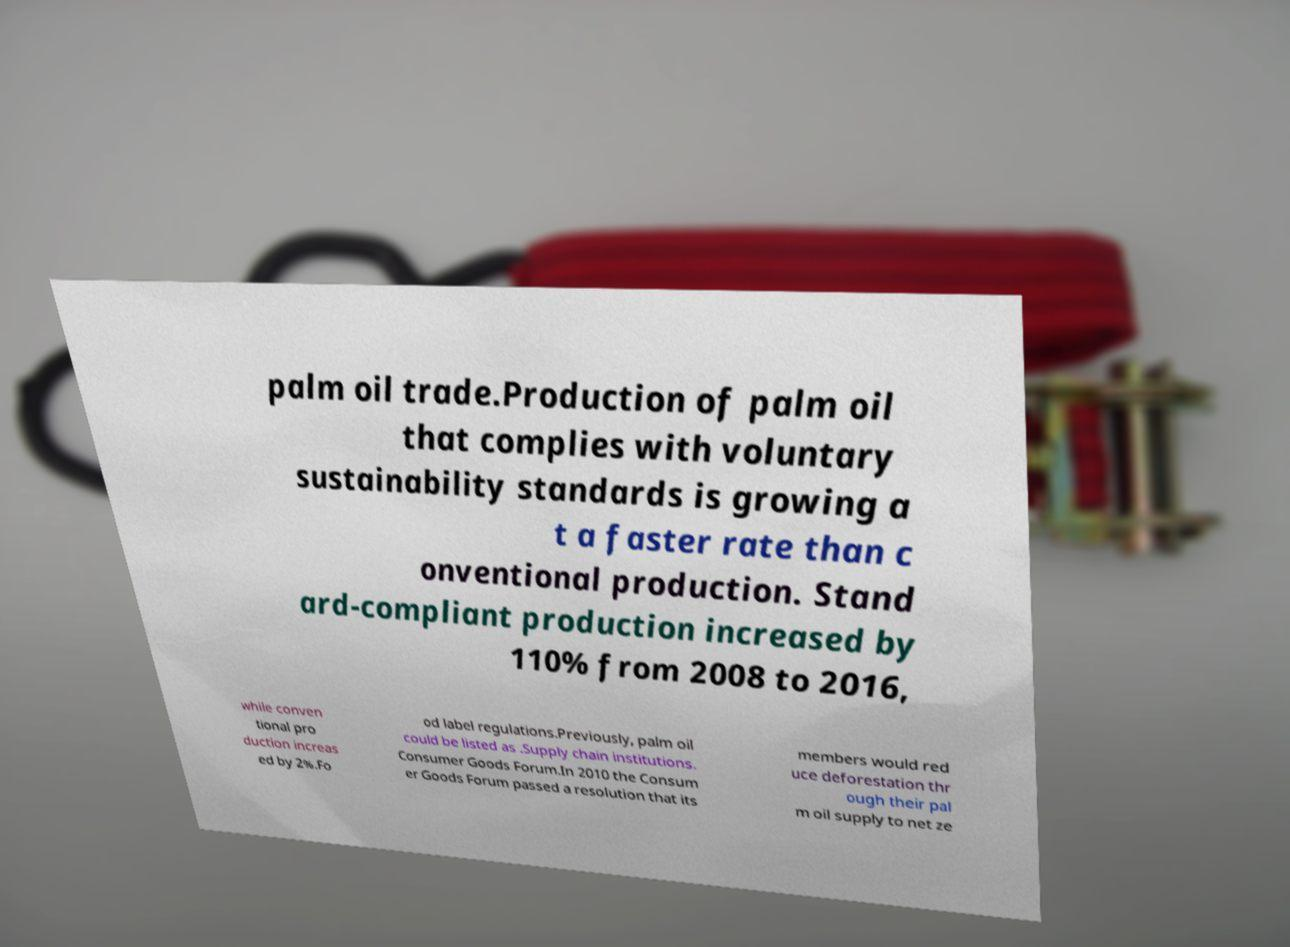There's text embedded in this image that I need extracted. Can you transcribe it verbatim? palm oil trade.Production of palm oil that complies with voluntary sustainability standards is growing a t a faster rate than c onventional production. Stand ard-compliant production increased by 110% from 2008 to 2016, while conven tional pro duction increas ed by 2%.Fo od label regulations.Previously, palm oil could be listed as .Supply chain institutions. Consumer Goods Forum.In 2010 the Consum er Goods Forum passed a resolution that its members would red uce deforestation thr ough their pal m oil supply to net ze 